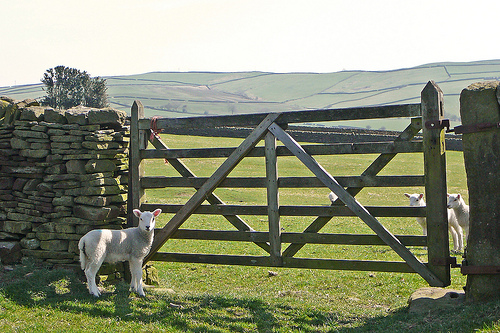Tell me more about the fencing seen in the image. The fence in the image is a traditional wooden gate, which is common in agricultural areas for controlling the movement of livestock. It's designed to be sturdy yet easy for farmers to operate, often leading into new pastures or pens. How does this type of gate benefit the farmers? This type of gate allows farmers to easily manage the flow of livestock between different sections of the farm without requiring additional manpower. It's a simple yet effective solution to keep the animals contained in desired areas, ensuring their safety and easing the process of grazing management. 